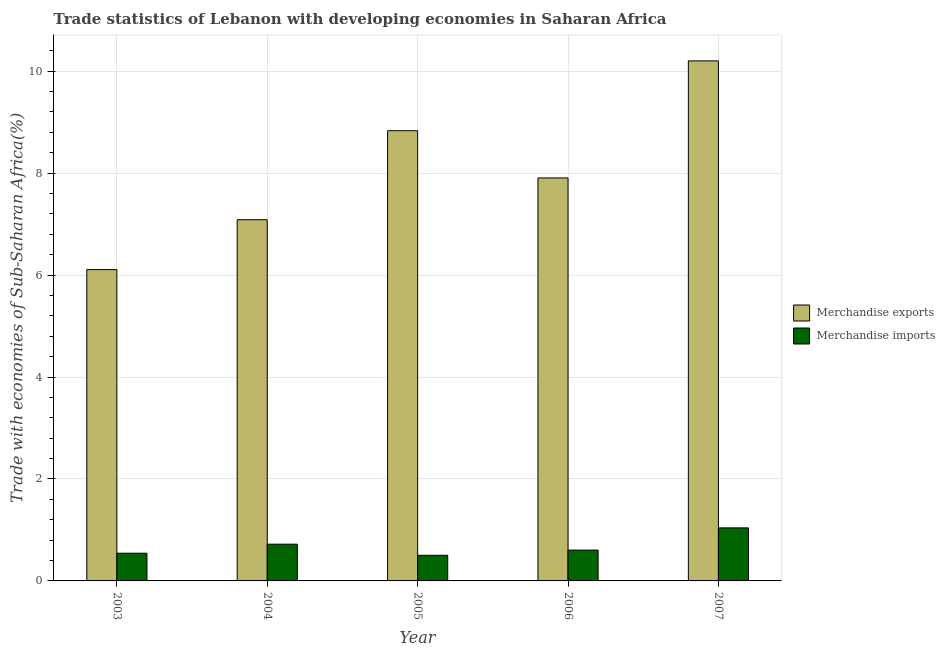How many different coloured bars are there?
Make the answer very short. 2. How many groups of bars are there?
Your answer should be compact. 5. Are the number of bars per tick equal to the number of legend labels?
Make the answer very short. Yes. Are the number of bars on each tick of the X-axis equal?
Make the answer very short. Yes. How many bars are there on the 2nd tick from the left?
Offer a terse response. 2. What is the merchandise imports in 2004?
Offer a terse response. 0.72. Across all years, what is the maximum merchandise exports?
Your answer should be very brief. 10.2. Across all years, what is the minimum merchandise exports?
Provide a short and direct response. 6.11. In which year was the merchandise exports maximum?
Give a very brief answer. 2007. In which year was the merchandise exports minimum?
Offer a very short reply. 2003. What is the total merchandise imports in the graph?
Offer a terse response. 3.41. What is the difference between the merchandise exports in 2003 and that in 2007?
Ensure brevity in your answer.  -4.09. What is the difference between the merchandise imports in 2003 and the merchandise exports in 2007?
Give a very brief answer. -0.5. What is the average merchandise exports per year?
Offer a terse response. 8.03. In the year 2004, what is the difference between the merchandise imports and merchandise exports?
Ensure brevity in your answer.  0. What is the ratio of the merchandise imports in 2003 to that in 2007?
Your answer should be compact. 0.52. Is the merchandise exports in 2003 less than that in 2006?
Keep it short and to the point. Yes. What is the difference between the highest and the second highest merchandise exports?
Make the answer very short. 1.37. What is the difference between the highest and the lowest merchandise exports?
Offer a very short reply. 4.09. In how many years, is the merchandise imports greater than the average merchandise imports taken over all years?
Give a very brief answer. 2. Are all the bars in the graph horizontal?
Ensure brevity in your answer.  No. What is the difference between two consecutive major ticks on the Y-axis?
Give a very brief answer. 2. Are the values on the major ticks of Y-axis written in scientific E-notation?
Offer a very short reply. No. Does the graph contain grids?
Ensure brevity in your answer.  Yes. What is the title of the graph?
Ensure brevity in your answer.  Trade statistics of Lebanon with developing economies in Saharan Africa. Does "Largest city" appear as one of the legend labels in the graph?
Make the answer very short. No. What is the label or title of the Y-axis?
Give a very brief answer. Trade with economies of Sub-Saharan Africa(%). What is the Trade with economies of Sub-Saharan Africa(%) of Merchandise exports in 2003?
Your response must be concise. 6.11. What is the Trade with economies of Sub-Saharan Africa(%) in Merchandise imports in 2003?
Offer a very short reply. 0.54. What is the Trade with economies of Sub-Saharan Africa(%) of Merchandise exports in 2004?
Give a very brief answer. 7.09. What is the Trade with economies of Sub-Saharan Africa(%) of Merchandise imports in 2004?
Provide a short and direct response. 0.72. What is the Trade with economies of Sub-Saharan Africa(%) in Merchandise exports in 2005?
Offer a very short reply. 8.83. What is the Trade with economies of Sub-Saharan Africa(%) in Merchandise imports in 2005?
Your response must be concise. 0.5. What is the Trade with economies of Sub-Saharan Africa(%) of Merchandise exports in 2006?
Ensure brevity in your answer.  7.91. What is the Trade with economies of Sub-Saharan Africa(%) in Merchandise imports in 2006?
Ensure brevity in your answer.  0.6. What is the Trade with economies of Sub-Saharan Africa(%) of Merchandise exports in 2007?
Offer a terse response. 10.2. What is the Trade with economies of Sub-Saharan Africa(%) in Merchandise imports in 2007?
Give a very brief answer. 1.04. Across all years, what is the maximum Trade with economies of Sub-Saharan Africa(%) of Merchandise exports?
Keep it short and to the point. 10.2. Across all years, what is the maximum Trade with economies of Sub-Saharan Africa(%) in Merchandise imports?
Your answer should be very brief. 1.04. Across all years, what is the minimum Trade with economies of Sub-Saharan Africa(%) of Merchandise exports?
Provide a short and direct response. 6.11. Across all years, what is the minimum Trade with economies of Sub-Saharan Africa(%) of Merchandise imports?
Your response must be concise. 0.5. What is the total Trade with economies of Sub-Saharan Africa(%) of Merchandise exports in the graph?
Provide a short and direct response. 40.13. What is the total Trade with economies of Sub-Saharan Africa(%) in Merchandise imports in the graph?
Ensure brevity in your answer.  3.41. What is the difference between the Trade with economies of Sub-Saharan Africa(%) of Merchandise exports in 2003 and that in 2004?
Ensure brevity in your answer.  -0.98. What is the difference between the Trade with economies of Sub-Saharan Africa(%) of Merchandise imports in 2003 and that in 2004?
Keep it short and to the point. -0.18. What is the difference between the Trade with economies of Sub-Saharan Africa(%) in Merchandise exports in 2003 and that in 2005?
Give a very brief answer. -2.72. What is the difference between the Trade with economies of Sub-Saharan Africa(%) in Merchandise imports in 2003 and that in 2005?
Ensure brevity in your answer.  0.04. What is the difference between the Trade with economies of Sub-Saharan Africa(%) in Merchandise exports in 2003 and that in 2006?
Offer a very short reply. -1.8. What is the difference between the Trade with economies of Sub-Saharan Africa(%) of Merchandise imports in 2003 and that in 2006?
Your response must be concise. -0.06. What is the difference between the Trade with economies of Sub-Saharan Africa(%) in Merchandise exports in 2003 and that in 2007?
Make the answer very short. -4.09. What is the difference between the Trade with economies of Sub-Saharan Africa(%) in Merchandise imports in 2003 and that in 2007?
Your answer should be very brief. -0.5. What is the difference between the Trade with economies of Sub-Saharan Africa(%) of Merchandise exports in 2004 and that in 2005?
Provide a short and direct response. -1.75. What is the difference between the Trade with economies of Sub-Saharan Africa(%) in Merchandise imports in 2004 and that in 2005?
Offer a very short reply. 0.22. What is the difference between the Trade with economies of Sub-Saharan Africa(%) in Merchandise exports in 2004 and that in 2006?
Your response must be concise. -0.82. What is the difference between the Trade with economies of Sub-Saharan Africa(%) in Merchandise imports in 2004 and that in 2006?
Keep it short and to the point. 0.12. What is the difference between the Trade with economies of Sub-Saharan Africa(%) of Merchandise exports in 2004 and that in 2007?
Offer a very short reply. -3.12. What is the difference between the Trade with economies of Sub-Saharan Africa(%) of Merchandise imports in 2004 and that in 2007?
Your answer should be compact. -0.32. What is the difference between the Trade with economies of Sub-Saharan Africa(%) of Merchandise exports in 2005 and that in 2006?
Provide a short and direct response. 0.93. What is the difference between the Trade with economies of Sub-Saharan Africa(%) of Merchandise imports in 2005 and that in 2006?
Keep it short and to the point. -0.1. What is the difference between the Trade with economies of Sub-Saharan Africa(%) of Merchandise exports in 2005 and that in 2007?
Offer a very short reply. -1.37. What is the difference between the Trade with economies of Sub-Saharan Africa(%) in Merchandise imports in 2005 and that in 2007?
Your answer should be very brief. -0.54. What is the difference between the Trade with economies of Sub-Saharan Africa(%) of Merchandise exports in 2006 and that in 2007?
Offer a terse response. -2.3. What is the difference between the Trade with economies of Sub-Saharan Africa(%) of Merchandise imports in 2006 and that in 2007?
Your answer should be very brief. -0.44. What is the difference between the Trade with economies of Sub-Saharan Africa(%) in Merchandise exports in 2003 and the Trade with economies of Sub-Saharan Africa(%) in Merchandise imports in 2004?
Offer a very short reply. 5.39. What is the difference between the Trade with economies of Sub-Saharan Africa(%) of Merchandise exports in 2003 and the Trade with economies of Sub-Saharan Africa(%) of Merchandise imports in 2005?
Ensure brevity in your answer.  5.6. What is the difference between the Trade with economies of Sub-Saharan Africa(%) in Merchandise exports in 2003 and the Trade with economies of Sub-Saharan Africa(%) in Merchandise imports in 2006?
Your response must be concise. 5.5. What is the difference between the Trade with economies of Sub-Saharan Africa(%) of Merchandise exports in 2003 and the Trade with economies of Sub-Saharan Africa(%) of Merchandise imports in 2007?
Ensure brevity in your answer.  5.07. What is the difference between the Trade with economies of Sub-Saharan Africa(%) of Merchandise exports in 2004 and the Trade with economies of Sub-Saharan Africa(%) of Merchandise imports in 2005?
Provide a short and direct response. 6.58. What is the difference between the Trade with economies of Sub-Saharan Africa(%) in Merchandise exports in 2004 and the Trade with economies of Sub-Saharan Africa(%) in Merchandise imports in 2006?
Offer a very short reply. 6.48. What is the difference between the Trade with economies of Sub-Saharan Africa(%) of Merchandise exports in 2004 and the Trade with economies of Sub-Saharan Africa(%) of Merchandise imports in 2007?
Your answer should be compact. 6.05. What is the difference between the Trade with economies of Sub-Saharan Africa(%) in Merchandise exports in 2005 and the Trade with economies of Sub-Saharan Africa(%) in Merchandise imports in 2006?
Your response must be concise. 8.23. What is the difference between the Trade with economies of Sub-Saharan Africa(%) of Merchandise exports in 2005 and the Trade with economies of Sub-Saharan Africa(%) of Merchandise imports in 2007?
Your answer should be very brief. 7.79. What is the difference between the Trade with economies of Sub-Saharan Africa(%) in Merchandise exports in 2006 and the Trade with economies of Sub-Saharan Africa(%) in Merchandise imports in 2007?
Offer a very short reply. 6.86. What is the average Trade with economies of Sub-Saharan Africa(%) in Merchandise exports per year?
Provide a succinct answer. 8.03. What is the average Trade with economies of Sub-Saharan Africa(%) of Merchandise imports per year?
Your response must be concise. 0.68. In the year 2003, what is the difference between the Trade with economies of Sub-Saharan Africa(%) in Merchandise exports and Trade with economies of Sub-Saharan Africa(%) in Merchandise imports?
Offer a terse response. 5.56. In the year 2004, what is the difference between the Trade with economies of Sub-Saharan Africa(%) of Merchandise exports and Trade with economies of Sub-Saharan Africa(%) of Merchandise imports?
Provide a succinct answer. 6.37. In the year 2005, what is the difference between the Trade with economies of Sub-Saharan Africa(%) of Merchandise exports and Trade with economies of Sub-Saharan Africa(%) of Merchandise imports?
Offer a very short reply. 8.33. In the year 2006, what is the difference between the Trade with economies of Sub-Saharan Africa(%) of Merchandise exports and Trade with economies of Sub-Saharan Africa(%) of Merchandise imports?
Your response must be concise. 7.3. In the year 2007, what is the difference between the Trade with economies of Sub-Saharan Africa(%) in Merchandise exports and Trade with economies of Sub-Saharan Africa(%) in Merchandise imports?
Ensure brevity in your answer.  9.16. What is the ratio of the Trade with economies of Sub-Saharan Africa(%) in Merchandise exports in 2003 to that in 2004?
Provide a succinct answer. 0.86. What is the ratio of the Trade with economies of Sub-Saharan Africa(%) in Merchandise imports in 2003 to that in 2004?
Provide a succinct answer. 0.75. What is the ratio of the Trade with economies of Sub-Saharan Africa(%) in Merchandise exports in 2003 to that in 2005?
Give a very brief answer. 0.69. What is the ratio of the Trade with economies of Sub-Saharan Africa(%) of Merchandise imports in 2003 to that in 2005?
Your answer should be compact. 1.08. What is the ratio of the Trade with economies of Sub-Saharan Africa(%) of Merchandise exports in 2003 to that in 2006?
Your answer should be very brief. 0.77. What is the ratio of the Trade with economies of Sub-Saharan Africa(%) of Merchandise imports in 2003 to that in 2006?
Give a very brief answer. 0.9. What is the ratio of the Trade with economies of Sub-Saharan Africa(%) of Merchandise exports in 2003 to that in 2007?
Provide a succinct answer. 0.6. What is the ratio of the Trade with economies of Sub-Saharan Africa(%) in Merchandise imports in 2003 to that in 2007?
Make the answer very short. 0.52. What is the ratio of the Trade with economies of Sub-Saharan Africa(%) of Merchandise exports in 2004 to that in 2005?
Give a very brief answer. 0.8. What is the ratio of the Trade with economies of Sub-Saharan Africa(%) of Merchandise imports in 2004 to that in 2005?
Provide a succinct answer. 1.43. What is the ratio of the Trade with economies of Sub-Saharan Africa(%) of Merchandise exports in 2004 to that in 2006?
Provide a succinct answer. 0.9. What is the ratio of the Trade with economies of Sub-Saharan Africa(%) in Merchandise imports in 2004 to that in 2006?
Provide a succinct answer. 1.19. What is the ratio of the Trade with economies of Sub-Saharan Africa(%) of Merchandise exports in 2004 to that in 2007?
Ensure brevity in your answer.  0.69. What is the ratio of the Trade with economies of Sub-Saharan Africa(%) of Merchandise imports in 2004 to that in 2007?
Your answer should be compact. 0.69. What is the ratio of the Trade with economies of Sub-Saharan Africa(%) in Merchandise exports in 2005 to that in 2006?
Keep it short and to the point. 1.12. What is the ratio of the Trade with economies of Sub-Saharan Africa(%) in Merchandise imports in 2005 to that in 2006?
Your answer should be very brief. 0.83. What is the ratio of the Trade with economies of Sub-Saharan Africa(%) in Merchandise exports in 2005 to that in 2007?
Your response must be concise. 0.87. What is the ratio of the Trade with economies of Sub-Saharan Africa(%) in Merchandise imports in 2005 to that in 2007?
Provide a succinct answer. 0.48. What is the ratio of the Trade with economies of Sub-Saharan Africa(%) of Merchandise exports in 2006 to that in 2007?
Your response must be concise. 0.77. What is the ratio of the Trade with economies of Sub-Saharan Africa(%) in Merchandise imports in 2006 to that in 2007?
Make the answer very short. 0.58. What is the difference between the highest and the second highest Trade with economies of Sub-Saharan Africa(%) of Merchandise exports?
Provide a succinct answer. 1.37. What is the difference between the highest and the second highest Trade with economies of Sub-Saharan Africa(%) of Merchandise imports?
Provide a succinct answer. 0.32. What is the difference between the highest and the lowest Trade with economies of Sub-Saharan Africa(%) in Merchandise exports?
Give a very brief answer. 4.09. What is the difference between the highest and the lowest Trade with economies of Sub-Saharan Africa(%) of Merchandise imports?
Your answer should be very brief. 0.54. 